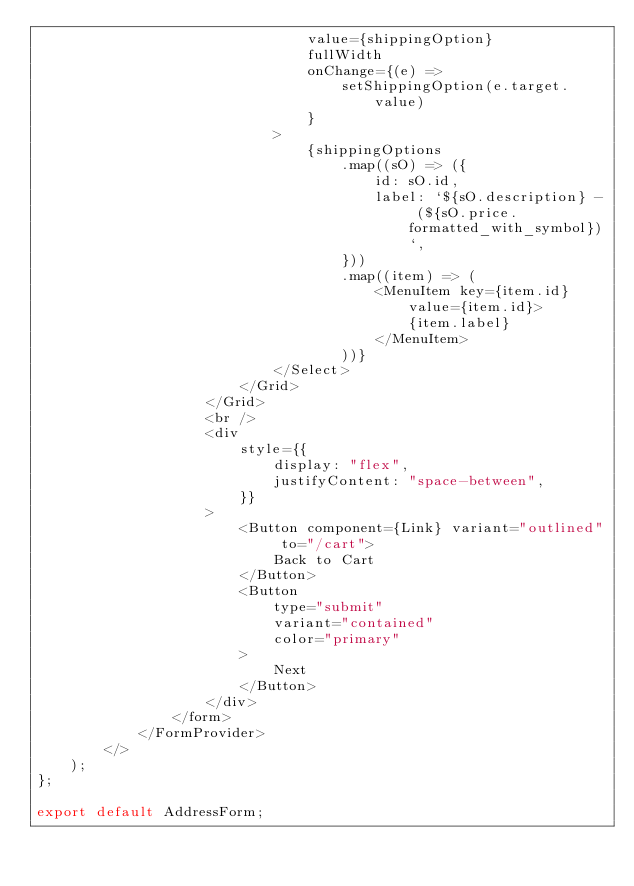Convert code to text. <code><loc_0><loc_0><loc_500><loc_500><_JavaScript_>                                value={shippingOption}
                                fullWidth
                                onChange={(e) =>
                                    setShippingOption(e.target.value)
                                }
                            >
                                {shippingOptions
                                    .map((sO) => ({
                                        id: sO.id,
                                        label: `${sO.description} - (${sO.price.formatted_with_symbol})`,
                                    }))
                                    .map((item) => (
                                        <MenuItem key={item.id} value={item.id}>
                                            {item.label}
                                        </MenuItem>
                                    ))}
                            </Select>
                        </Grid>
                    </Grid>
                    <br />
                    <div
                        style={{
                            display: "flex",
                            justifyContent: "space-between",
                        }}
                    >
                        <Button component={Link} variant="outlined" to="/cart">
                            Back to Cart
                        </Button>
                        <Button
                            type="submit"
                            variant="contained"
                            color="primary"
                        >
                            Next
                        </Button>
                    </div>
                </form>
            </FormProvider>
        </>
    );
};

export default AddressForm;
</code> 